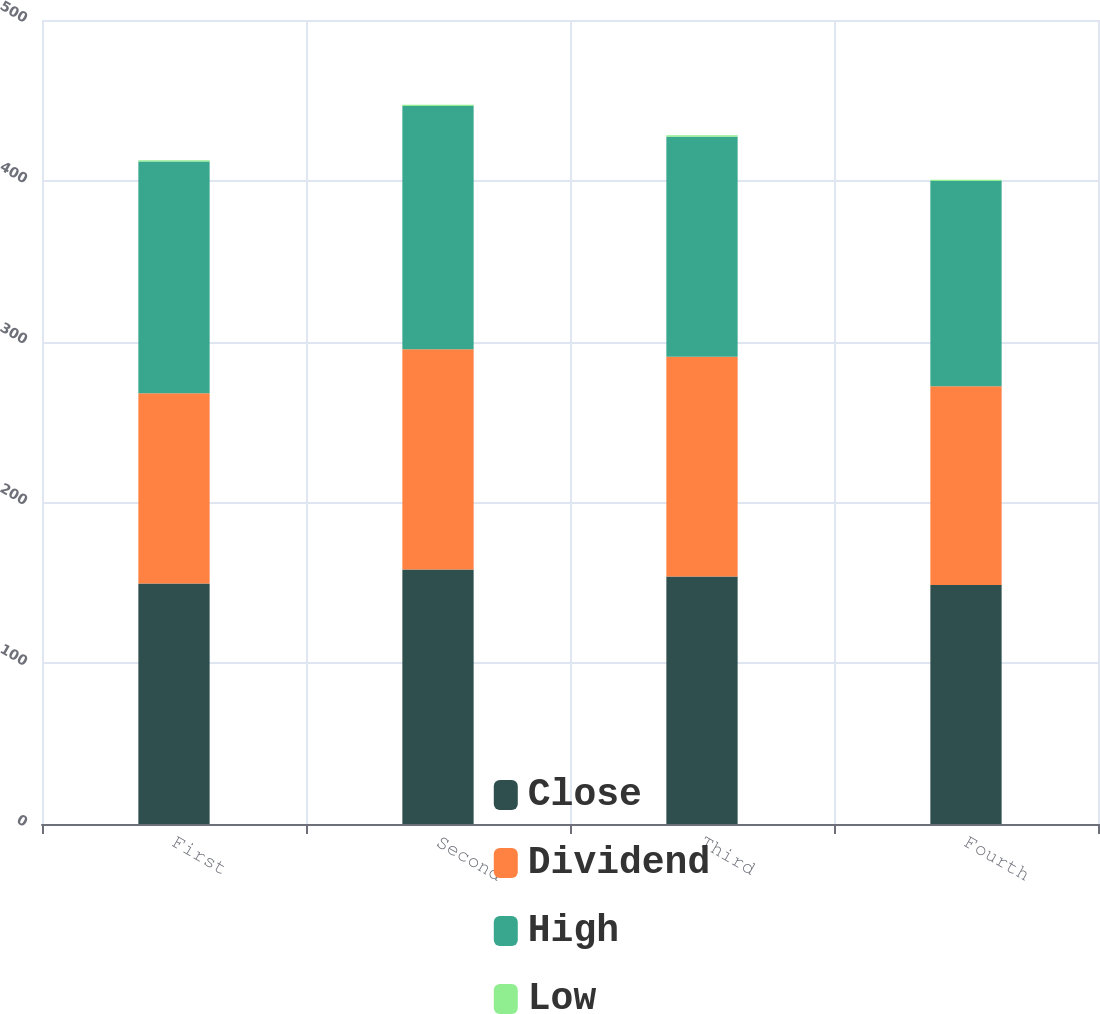Convert chart. <chart><loc_0><loc_0><loc_500><loc_500><stacked_bar_chart><ecel><fcel>First<fcel>Second<fcel>Third<fcel>Fourth<nl><fcel>Close<fcel>149.61<fcel>158.2<fcel>153.93<fcel>148.56<nl><fcel>Dividend<fcel>118.2<fcel>137.07<fcel>136.69<fcel>123.66<nl><fcel>High<fcel>144.23<fcel>151.28<fcel>136.83<fcel>127.58<nl><fcel>Low<fcel>0.77<fcel>0.81<fcel>0.81<fcel>0.81<nl></chart> 